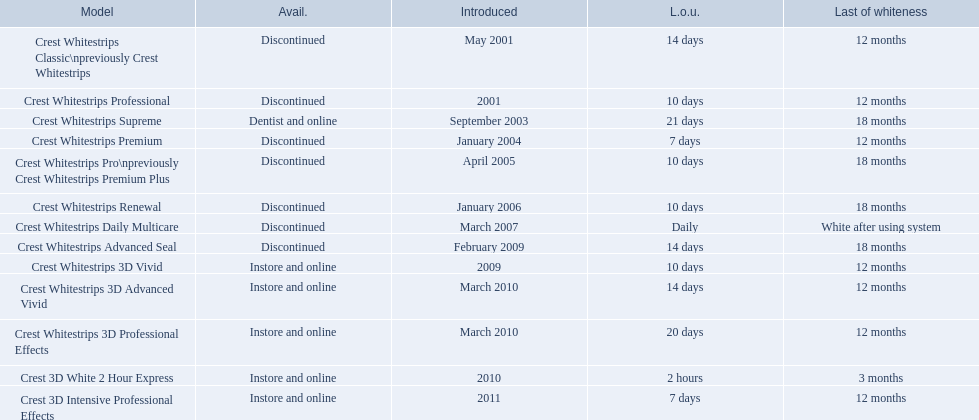What types of crest whitestrips have been released? Crest Whitestrips Classic\npreviously Crest Whitestrips, Crest Whitestrips Professional, Crest Whitestrips Supreme, Crest Whitestrips Premium, Crest Whitestrips Pro\npreviously Crest Whitestrips Premium Plus, Crest Whitestrips Renewal, Crest Whitestrips Daily Multicare, Crest Whitestrips Advanced Seal, Crest Whitestrips 3D Vivid, Crest Whitestrips 3D Advanced Vivid, Crest Whitestrips 3D Professional Effects, Crest 3D White 2 Hour Express, Crest 3D Intensive Professional Effects. What was the length of use for each type? 14 days, 10 days, 21 days, 7 days, 10 days, 10 days, Daily, 14 days, 10 days, 14 days, 20 days, 2 hours, 7 days. And how long did each last? 12 months, 12 months, 18 months, 12 months, 18 months, 18 months, White after using system, 18 months, 12 months, 12 months, 12 months, 3 months, 12 months. Of those models, which lasted the longest with the longest length of use? Crest Whitestrips Supreme. 